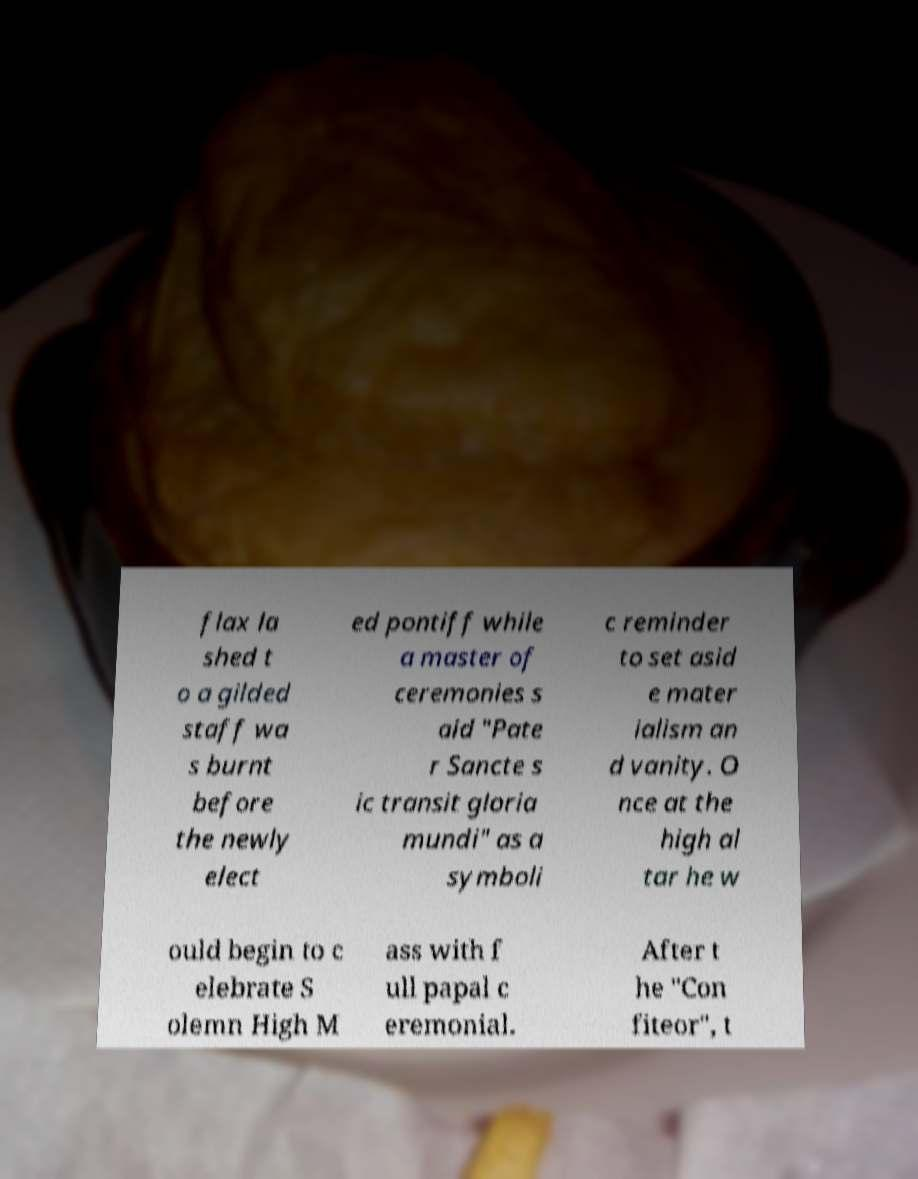Can you accurately transcribe the text from the provided image for me? flax la shed t o a gilded staff wa s burnt before the newly elect ed pontiff while a master of ceremonies s aid "Pate r Sancte s ic transit gloria mundi" as a symboli c reminder to set asid e mater ialism an d vanity. O nce at the high al tar he w ould begin to c elebrate S olemn High M ass with f ull papal c eremonial. After t he "Con fiteor", t 